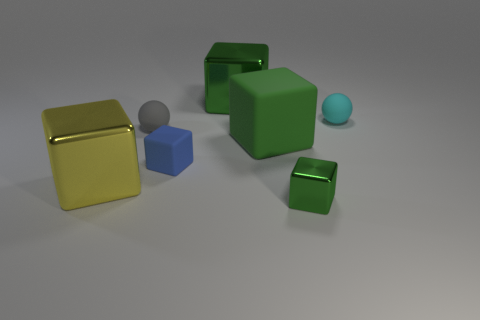The other shiny thing that is the same size as the cyan object is what color?
Offer a very short reply. Green. There is a matte cube that is to the left of the green thing that is behind the green matte thing; what size is it?
Offer a very short reply. Small. There is a big matte block; is it the same color as the big metallic thing behind the blue object?
Your answer should be compact. Yes. Are there fewer small cyan balls in front of the gray rubber ball than big yellow cubes?
Keep it short and to the point. Yes. How many other things are there of the same size as the cyan matte ball?
Make the answer very short. 3. Do the metallic object that is to the left of the gray thing and the small cyan rubber object have the same shape?
Give a very brief answer. No. Is the number of big things left of the tiny green shiny object greater than the number of small rubber objects?
Provide a succinct answer. No. There is a large thing that is in front of the gray object and to the right of the blue block; what material is it?
Provide a short and direct response. Rubber. What number of small matte objects are both in front of the tiny cyan thing and right of the big green metallic cube?
Ensure brevity in your answer.  0. What material is the yellow thing?
Offer a very short reply. Metal. 